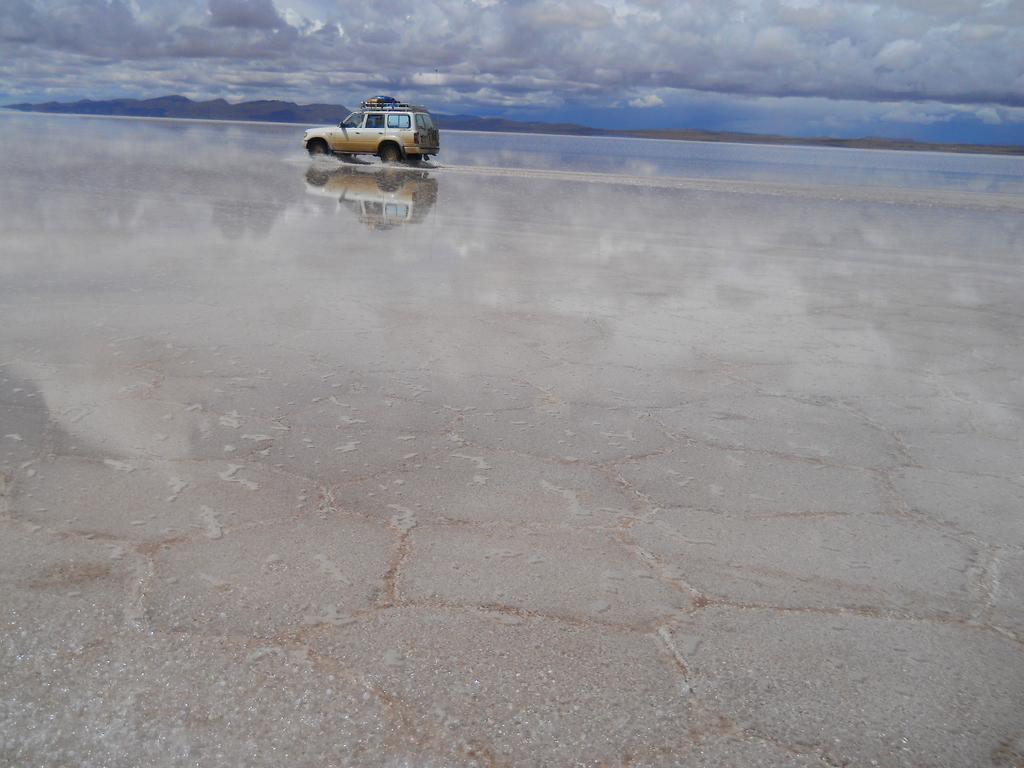What is happening in the image involving a vehicle? There is a vehicle moving on the road in the image. What can be seen in the air in the image? Smoke is visible in the image. What natural element is present in the image? Water is visible in the image. What type of landscape can be seen in the background of the image? There are hills in the background of the image. What is the condition of the sky in the background of the image? The sky is cloudy in the background of the image. What type of disease is affecting the leaves in the image? There are no leaves present in the image, so it is not possible to determine if any disease is affecting them. 